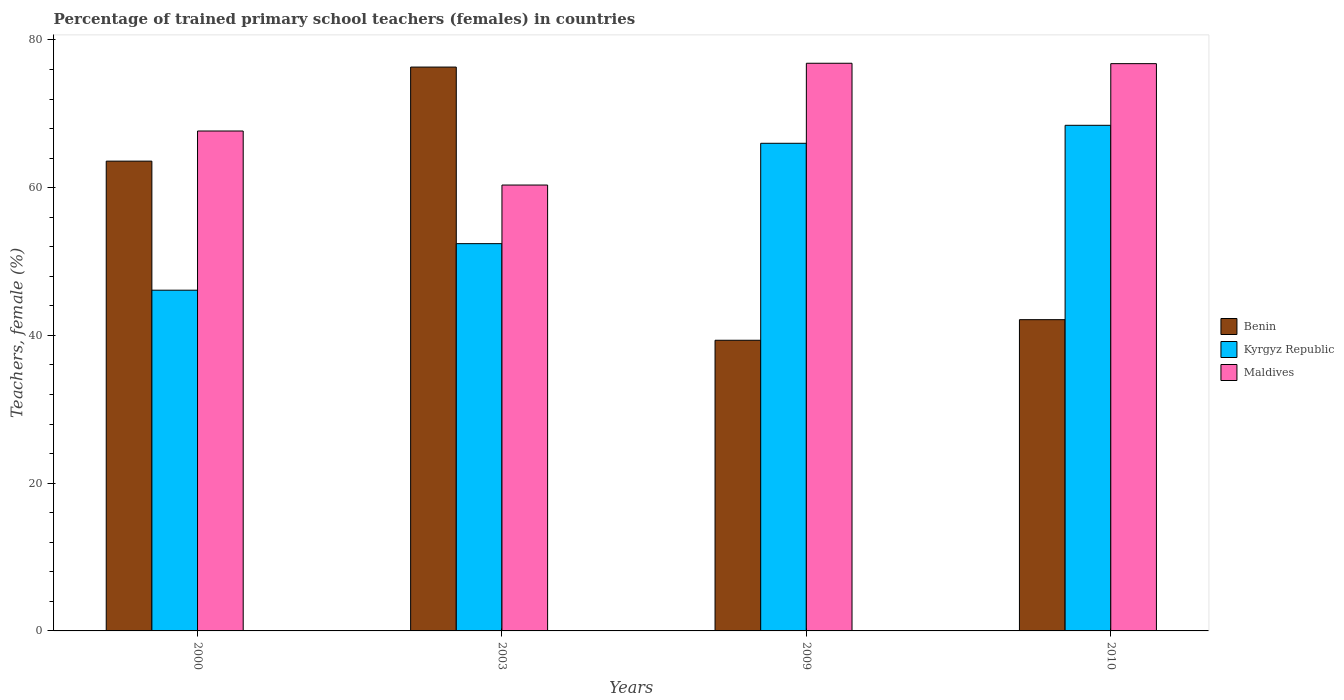How many different coloured bars are there?
Offer a very short reply. 3. Are the number of bars on each tick of the X-axis equal?
Keep it short and to the point. Yes. How many bars are there on the 1st tick from the right?
Your answer should be very brief. 3. In how many cases, is the number of bars for a given year not equal to the number of legend labels?
Make the answer very short. 0. What is the percentage of trained primary school teachers (females) in Benin in 2009?
Give a very brief answer. 39.35. Across all years, what is the maximum percentage of trained primary school teachers (females) in Benin?
Offer a very short reply. 76.33. Across all years, what is the minimum percentage of trained primary school teachers (females) in Benin?
Your response must be concise. 39.35. What is the total percentage of trained primary school teachers (females) in Kyrgyz Republic in the graph?
Give a very brief answer. 233.02. What is the difference between the percentage of trained primary school teachers (females) in Kyrgyz Republic in 2009 and that in 2010?
Ensure brevity in your answer.  -2.43. What is the difference between the percentage of trained primary school teachers (females) in Maldives in 2010 and the percentage of trained primary school teachers (females) in Benin in 2003?
Keep it short and to the point. 0.46. What is the average percentage of trained primary school teachers (females) in Benin per year?
Keep it short and to the point. 55.35. In the year 2009, what is the difference between the percentage of trained primary school teachers (females) in Kyrgyz Republic and percentage of trained primary school teachers (females) in Maldives?
Provide a short and direct response. -10.83. In how many years, is the percentage of trained primary school teachers (females) in Benin greater than 68 %?
Your response must be concise. 1. What is the ratio of the percentage of trained primary school teachers (females) in Maldives in 2000 to that in 2009?
Give a very brief answer. 0.88. What is the difference between the highest and the second highest percentage of trained primary school teachers (females) in Benin?
Your answer should be compact. 12.73. What is the difference between the highest and the lowest percentage of trained primary school teachers (females) in Kyrgyz Republic?
Give a very brief answer. 22.32. In how many years, is the percentage of trained primary school teachers (females) in Benin greater than the average percentage of trained primary school teachers (females) in Benin taken over all years?
Provide a short and direct response. 2. Is the sum of the percentage of trained primary school teachers (females) in Benin in 2000 and 2010 greater than the maximum percentage of trained primary school teachers (females) in Kyrgyz Republic across all years?
Offer a terse response. Yes. What does the 2nd bar from the left in 2003 represents?
Your answer should be very brief. Kyrgyz Republic. What does the 1st bar from the right in 2000 represents?
Offer a very short reply. Maldives. Is it the case that in every year, the sum of the percentage of trained primary school teachers (females) in Maldives and percentage of trained primary school teachers (females) in Benin is greater than the percentage of trained primary school teachers (females) in Kyrgyz Republic?
Make the answer very short. Yes. How many bars are there?
Provide a succinct answer. 12. Are all the bars in the graph horizontal?
Your answer should be compact. No. What is the difference between two consecutive major ticks on the Y-axis?
Your answer should be compact. 20. Are the values on the major ticks of Y-axis written in scientific E-notation?
Give a very brief answer. No. Where does the legend appear in the graph?
Provide a short and direct response. Center right. How many legend labels are there?
Your response must be concise. 3. How are the legend labels stacked?
Provide a succinct answer. Vertical. What is the title of the graph?
Provide a succinct answer. Percentage of trained primary school teachers (females) in countries. Does "Cabo Verde" appear as one of the legend labels in the graph?
Offer a terse response. No. What is the label or title of the Y-axis?
Your answer should be very brief. Teachers, female (%). What is the Teachers, female (%) of Benin in 2000?
Offer a very short reply. 63.6. What is the Teachers, female (%) in Kyrgyz Republic in 2000?
Provide a succinct answer. 46.13. What is the Teachers, female (%) of Maldives in 2000?
Keep it short and to the point. 67.68. What is the Teachers, female (%) of Benin in 2003?
Your answer should be very brief. 76.33. What is the Teachers, female (%) in Kyrgyz Republic in 2003?
Ensure brevity in your answer.  52.43. What is the Teachers, female (%) of Maldives in 2003?
Make the answer very short. 60.36. What is the Teachers, female (%) in Benin in 2009?
Provide a succinct answer. 39.35. What is the Teachers, female (%) of Kyrgyz Republic in 2009?
Offer a terse response. 66.01. What is the Teachers, female (%) of Maldives in 2009?
Give a very brief answer. 76.85. What is the Teachers, female (%) in Benin in 2010?
Keep it short and to the point. 42.14. What is the Teachers, female (%) of Kyrgyz Republic in 2010?
Offer a terse response. 68.45. What is the Teachers, female (%) in Maldives in 2010?
Give a very brief answer. 76.8. Across all years, what is the maximum Teachers, female (%) of Benin?
Your response must be concise. 76.33. Across all years, what is the maximum Teachers, female (%) of Kyrgyz Republic?
Your answer should be compact. 68.45. Across all years, what is the maximum Teachers, female (%) of Maldives?
Your answer should be compact. 76.85. Across all years, what is the minimum Teachers, female (%) in Benin?
Make the answer very short. 39.35. Across all years, what is the minimum Teachers, female (%) in Kyrgyz Republic?
Your answer should be compact. 46.13. Across all years, what is the minimum Teachers, female (%) of Maldives?
Your answer should be compact. 60.36. What is the total Teachers, female (%) of Benin in the graph?
Your answer should be compact. 221.42. What is the total Teachers, female (%) of Kyrgyz Republic in the graph?
Offer a terse response. 233.02. What is the total Teachers, female (%) of Maldives in the graph?
Ensure brevity in your answer.  281.68. What is the difference between the Teachers, female (%) of Benin in 2000 and that in 2003?
Offer a very short reply. -12.73. What is the difference between the Teachers, female (%) of Kyrgyz Republic in 2000 and that in 2003?
Provide a short and direct response. -6.3. What is the difference between the Teachers, female (%) in Maldives in 2000 and that in 2003?
Offer a very short reply. 7.32. What is the difference between the Teachers, female (%) in Benin in 2000 and that in 2009?
Your response must be concise. 24.25. What is the difference between the Teachers, female (%) of Kyrgyz Republic in 2000 and that in 2009?
Give a very brief answer. -19.89. What is the difference between the Teachers, female (%) of Maldives in 2000 and that in 2009?
Offer a terse response. -9.17. What is the difference between the Teachers, female (%) of Benin in 2000 and that in 2010?
Your answer should be very brief. 21.46. What is the difference between the Teachers, female (%) in Kyrgyz Republic in 2000 and that in 2010?
Provide a succinct answer. -22.32. What is the difference between the Teachers, female (%) in Maldives in 2000 and that in 2010?
Your response must be concise. -9.12. What is the difference between the Teachers, female (%) in Benin in 2003 and that in 2009?
Make the answer very short. 36.98. What is the difference between the Teachers, female (%) in Kyrgyz Republic in 2003 and that in 2009?
Your response must be concise. -13.59. What is the difference between the Teachers, female (%) in Maldives in 2003 and that in 2009?
Your answer should be very brief. -16.49. What is the difference between the Teachers, female (%) of Benin in 2003 and that in 2010?
Provide a short and direct response. 34.19. What is the difference between the Teachers, female (%) of Kyrgyz Republic in 2003 and that in 2010?
Make the answer very short. -16.02. What is the difference between the Teachers, female (%) of Maldives in 2003 and that in 2010?
Provide a short and direct response. -16.43. What is the difference between the Teachers, female (%) of Benin in 2009 and that in 2010?
Provide a short and direct response. -2.79. What is the difference between the Teachers, female (%) of Kyrgyz Republic in 2009 and that in 2010?
Your response must be concise. -2.43. What is the difference between the Teachers, female (%) in Maldives in 2009 and that in 2010?
Provide a succinct answer. 0.05. What is the difference between the Teachers, female (%) in Benin in 2000 and the Teachers, female (%) in Kyrgyz Republic in 2003?
Provide a short and direct response. 11.17. What is the difference between the Teachers, female (%) in Benin in 2000 and the Teachers, female (%) in Maldives in 2003?
Make the answer very short. 3.24. What is the difference between the Teachers, female (%) of Kyrgyz Republic in 2000 and the Teachers, female (%) of Maldives in 2003?
Provide a short and direct response. -14.24. What is the difference between the Teachers, female (%) in Benin in 2000 and the Teachers, female (%) in Kyrgyz Republic in 2009?
Make the answer very short. -2.42. What is the difference between the Teachers, female (%) of Benin in 2000 and the Teachers, female (%) of Maldives in 2009?
Keep it short and to the point. -13.25. What is the difference between the Teachers, female (%) in Kyrgyz Republic in 2000 and the Teachers, female (%) in Maldives in 2009?
Provide a succinct answer. -30.72. What is the difference between the Teachers, female (%) of Benin in 2000 and the Teachers, female (%) of Kyrgyz Republic in 2010?
Your answer should be compact. -4.85. What is the difference between the Teachers, female (%) in Benin in 2000 and the Teachers, female (%) in Maldives in 2010?
Make the answer very short. -13.2. What is the difference between the Teachers, female (%) in Kyrgyz Republic in 2000 and the Teachers, female (%) in Maldives in 2010?
Keep it short and to the point. -30.67. What is the difference between the Teachers, female (%) of Benin in 2003 and the Teachers, female (%) of Kyrgyz Republic in 2009?
Offer a very short reply. 10.32. What is the difference between the Teachers, female (%) in Benin in 2003 and the Teachers, female (%) in Maldives in 2009?
Offer a terse response. -0.52. What is the difference between the Teachers, female (%) of Kyrgyz Republic in 2003 and the Teachers, female (%) of Maldives in 2009?
Your answer should be very brief. -24.42. What is the difference between the Teachers, female (%) of Benin in 2003 and the Teachers, female (%) of Kyrgyz Republic in 2010?
Your answer should be very brief. 7.88. What is the difference between the Teachers, female (%) of Benin in 2003 and the Teachers, female (%) of Maldives in 2010?
Make the answer very short. -0.46. What is the difference between the Teachers, female (%) in Kyrgyz Republic in 2003 and the Teachers, female (%) in Maldives in 2010?
Offer a very short reply. -24.37. What is the difference between the Teachers, female (%) in Benin in 2009 and the Teachers, female (%) in Kyrgyz Republic in 2010?
Your answer should be very brief. -29.1. What is the difference between the Teachers, female (%) of Benin in 2009 and the Teachers, female (%) of Maldives in 2010?
Provide a succinct answer. -37.45. What is the difference between the Teachers, female (%) in Kyrgyz Republic in 2009 and the Teachers, female (%) in Maldives in 2010?
Your answer should be very brief. -10.78. What is the average Teachers, female (%) in Benin per year?
Provide a succinct answer. 55.35. What is the average Teachers, female (%) of Kyrgyz Republic per year?
Provide a short and direct response. 58.25. What is the average Teachers, female (%) in Maldives per year?
Offer a terse response. 70.42. In the year 2000, what is the difference between the Teachers, female (%) of Benin and Teachers, female (%) of Kyrgyz Republic?
Your answer should be compact. 17.47. In the year 2000, what is the difference between the Teachers, female (%) of Benin and Teachers, female (%) of Maldives?
Offer a terse response. -4.08. In the year 2000, what is the difference between the Teachers, female (%) of Kyrgyz Republic and Teachers, female (%) of Maldives?
Your response must be concise. -21.55. In the year 2003, what is the difference between the Teachers, female (%) of Benin and Teachers, female (%) of Kyrgyz Republic?
Ensure brevity in your answer.  23.9. In the year 2003, what is the difference between the Teachers, female (%) in Benin and Teachers, female (%) in Maldives?
Your response must be concise. 15.97. In the year 2003, what is the difference between the Teachers, female (%) in Kyrgyz Republic and Teachers, female (%) in Maldives?
Offer a very short reply. -7.93. In the year 2009, what is the difference between the Teachers, female (%) in Benin and Teachers, female (%) in Kyrgyz Republic?
Provide a succinct answer. -26.67. In the year 2009, what is the difference between the Teachers, female (%) in Benin and Teachers, female (%) in Maldives?
Provide a short and direct response. -37.5. In the year 2009, what is the difference between the Teachers, female (%) of Kyrgyz Republic and Teachers, female (%) of Maldives?
Provide a succinct answer. -10.83. In the year 2010, what is the difference between the Teachers, female (%) in Benin and Teachers, female (%) in Kyrgyz Republic?
Provide a succinct answer. -26.31. In the year 2010, what is the difference between the Teachers, female (%) of Benin and Teachers, female (%) of Maldives?
Make the answer very short. -34.66. In the year 2010, what is the difference between the Teachers, female (%) in Kyrgyz Republic and Teachers, female (%) in Maldives?
Provide a succinct answer. -8.35. What is the ratio of the Teachers, female (%) of Benin in 2000 to that in 2003?
Keep it short and to the point. 0.83. What is the ratio of the Teachers, female (%) in Kyrgyz Republic in 2000 to that in 2003?
Offer a very short reply. 0.88. What is the ratio of the Teachers, female (%) of Maldives in 2000 to that in 2003?
Your response must be concise. 1.12. What is the ratio of the Teachers, female (%) in Benin in 2000 to that in 2009?
Provide a succinct answer. 1.62. What is the ratio of the Teachers, female (%) of Kyrgyz Republic in 2000 to that in 2009?
Your response must be concise. 0.7. What is the ratio of the Teachers, female (%) in Maldives in 2000 to that in 2009?
Offer a very short reply. 0.88. What is the ratio of the Teachers, female (%) of Benin in 2000 to that in 2010?
Give a very brief answer. 1.51. What is the ratio of the Teachers, female (%) in Kyrgyz Republic in 2000 to that in 2010?
Give a very brief answer. 0.67. What is the ratio of the Teachers, female (%) in Maldives in 2000 to that in 2010?
Provide a succinct answer. 0.88. What is the ratio of the Teachers, female (%) in Benin in 2003 to that in 2009?
Give a very brief answer. 1.94. What is the ratio of the Teachers, female (%) of Kyrgyz Republic in 2003 to that in 2009?
Give a very brief answer. 0.79. What is the ratio of the Teachers, female (%) of Maldives in 2003 to that in 2009?
Your answer should be very brief. 0.79. What is the ratio of the Teachers, female (%) in Benin in 2003 to that in 2010?
Provide a short and direct response. 1.81. What is the ratio of the Teachers, female (%) in Kyrgyz Republic in 2003 to that in 2010?
Keep it short and to the point. 0.77. What is the ratio of the Teachers, female (%) in Maldives in 2003 to that in 2010?
Your answer should be very brief. 0.79. What is the ratio of the Teachers, female (%) of Benin in 2009 to that in 2010?
Your answer should be compact. 0.93. What is the ratio of the Teachers, female (%) in Kyrgyz Republic in 2009 to that in 2010?
Offer a terse response. 0.96. What is the difference between the highest and the second highest Teachers, female (%) of Benin?
Give a very brief answer. 12.73. What is the difference between the highest and the second highest Teachers, female (%) of Kyrgyz Republic?
Your answer should be compact. 2.43. What is the difference between the highest and the second highest Teachers, female (%) in Maldives?
Offer a terse response. 0.05. What is the difference between the highest and the lowest Teachers, female (%) in Benin?
Give a very brief answer. 36.98. What is the difference between the highest and the lowest Teachers, female (%) in Kyrgyz Republic?
Ensure brevity in your answer.  22.32. What is the difference between the highest and the lowest Teachers, female (%) in Maldives?
Provide a short and direct response. 16.49. 